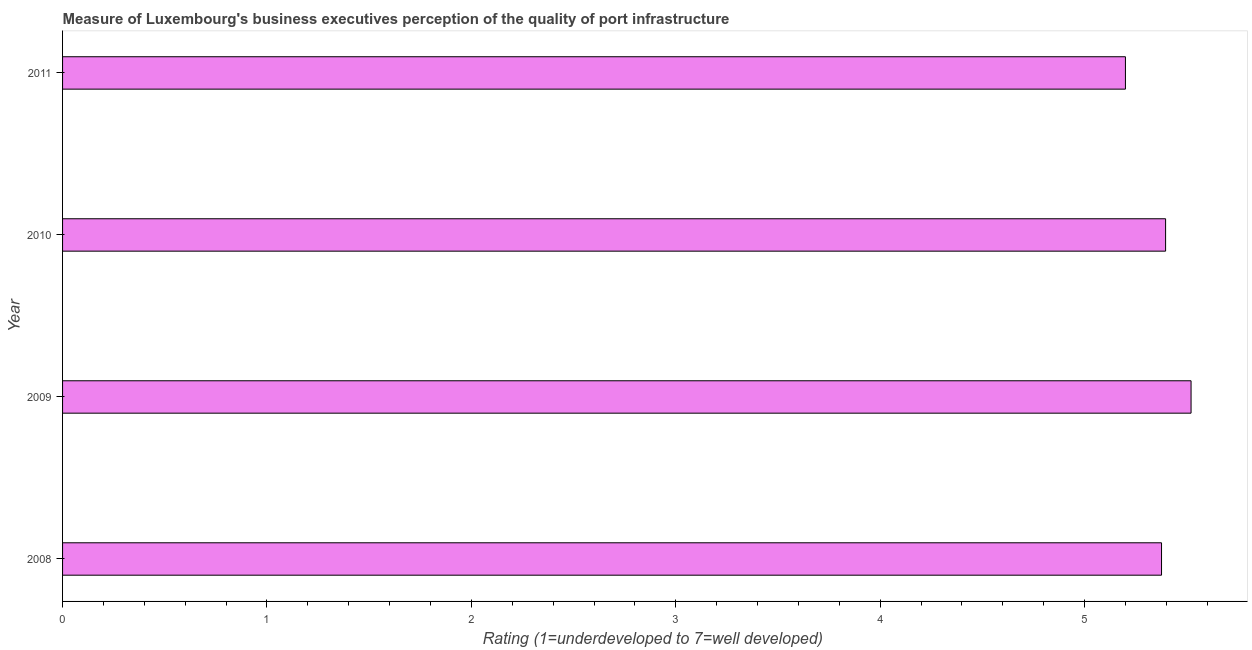Does the graph contain any zero values?
Keep it short and to the point. No. What is the title of the graph?
Your answer should be very brief. Measure of Luxembourg's business executives perception of the quality of port infrastructure. What is the label or title of the X-axis?
Your answer should be very brief. Rating (1=underdeveloped to 7=well developed) . What is the rating measuring quality of port infrastructure in 2011?
Your answer should be compact. 5.2. Across all years, what is the maximum rating measuring quality of port infrastructure?
Offer a terse response. 5.52. What is the sum of the rating measuring quality of port infrastructure?
Make the answer very short. 21.49. What is the difference between the rating measuring quality of port infrastructure in 2008 and 2009?
Your answer should be compact. -0.14. What is the average rating measuring quality of port infrastructure per year?
Keep it short and to the point. 5.37. What is the median rating measuring quality of port infrastructure?
Your response must be concise. 5.39. Is the rating measuring quality of port infrastructure in 2008 less than that in 2010?
Offer a terse response. Yes. Is the difference between the rating measuring quality of port infrastructure in 2008 and 2009 greater than the difference between any two years?
Keep it short and to the point. No. What is the difference between the highest and the second highest rating measuring quality of port infrastructure?
Keep it short and to the point. 0.12. What is the difference between the highest and the lowest rating measuring quality of port infrastructure?
Offer a very short reply. 0.32. In how many years, is the rating measuring quality of port infrastructure greater than the average rating measuring quality of port infrastructure taken over all years?
Offer a terse response. 3. How many years are there in the graph?
Provide a succinct answer. 4. What is the difference between two consecutive major ticks on the X-axis?
Offer a very short reply. 1. What is the Rating (1=underdeveloped to 7=well developed)  of 2008?
Your answer should be very brief. 5.38. What is the Rating (1=underdeveloped to 7=well developed)  of 2009?
Keep it short and to the point. 5.52. What is the Rating (1=underdeveloped to 7=well developed)  in 2010?
Keep it short and to the point. 5.4. What is the difference between the Rating (1=underdeveloped to 7=well developed)  in 2008 and 2009?
Your answer should be compact. -0.14. What is the difference between the Rating (1=underdeveloped to 7=well developed)  in 2008 and 2010?
Give a very brief answer. -0.02. What is the difference between the Rating (1=underdeveloped to 7=well developed)  in 2008 and 2011?
Offer a terse response. 0.18. What is the difference between the Rating (1=underdeveloped to 7=well developed)  in 2009 and 2010?
Your answer should be very brief. 0.12. What is the difference between the Rating (1=underdeveloped to 7=well developed)  in 2009 and 2011?
Offer a very short reply. 0.32. What is the difference between the Rating (1=underdeveloped to 7=well developed)  in 2010 and 2011?
Provide a succinct answer. 0.2. What is the ratio of the Rating (1=underdeveloped to 7=well developed)  in 2008 to that in 2011?
Give a very brief answer. 1.03. What is the ratio of the Rating (1=underdeveloped to 7=well developed)  in 2009 to that in 2011?
Offer a terse response. 1.06. What is the ratio of the Rating (1=underdeveloped to 7=well developed)  in 2010 to that in 2011?
Your answer should be compact. 1.04. 